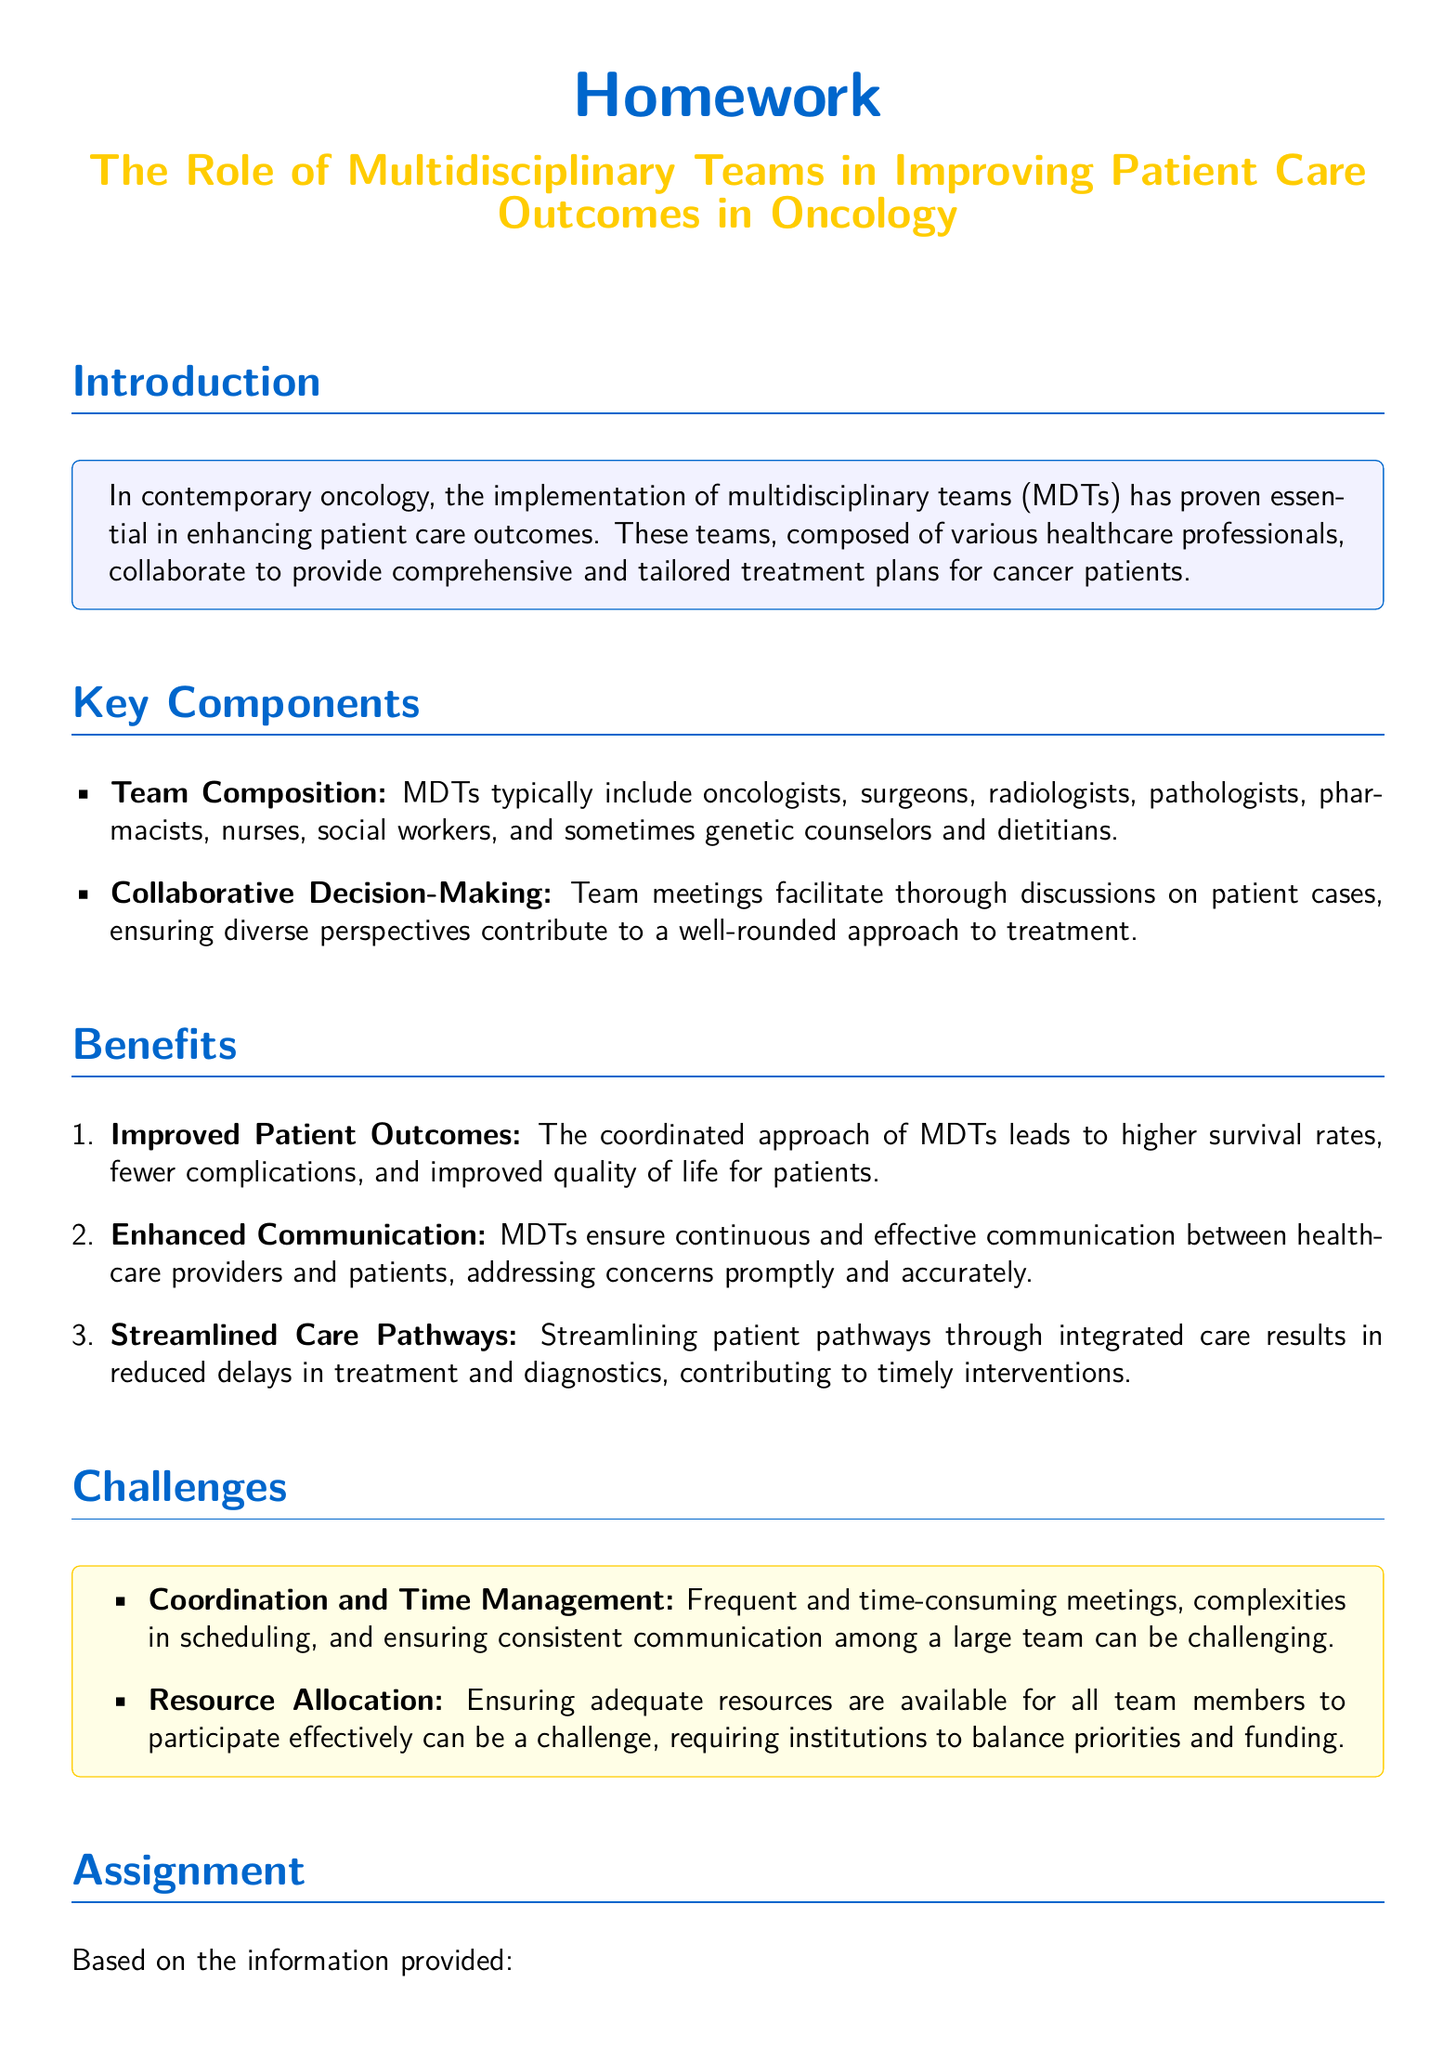What is the title of the homework? The title of the homework is found in the document's center section, which is focused on the role of multidisciplinary teams.
Answer: The Role of Multidisciplinary Teams in Improving Patient Care Outcomes in Oncology What professionals are typically included in a multidisciplinary team? The document lists the composition of MDTs, which includes various healthcare professionals collaborating for cancer treatment.
Answer: Oncologists, surgeons, radiologists, pathologists, pharmacists, nurses, social workers, genetic counselors, dietitians What is one key benefit of MDTs mentioned in the document? The document outlines several advantages of MDTs, emphasizing how they positively impact patient outcomes.
Answer: Improved Patient Outcomes What challenge faced by MDTs is highlighted in the text? The document addresses specific challenges that multidisciplinary teams encounter in their operations.
Answer: Coordination and Time Management How many pages should the report submitted be? The document specifies the length requirement for the report that students must submit.
Answer: 2-3 pages Which benefit involves improving communication between healthcare providers and patients? The document describes benefits of MDTs, including one focused on effective communication.
Answer: Enhanced Communication What does MDT stand for? The abbreviation is defined in the context of the document, referring to the team structure in oncology.
Answer: Multidisciplinary Team Name an example of a problem related to resources mentioned in the challenges. The document identifies issues regarding resources that can impact the efficacy of MDTs.
Answer: Resource Allocation 